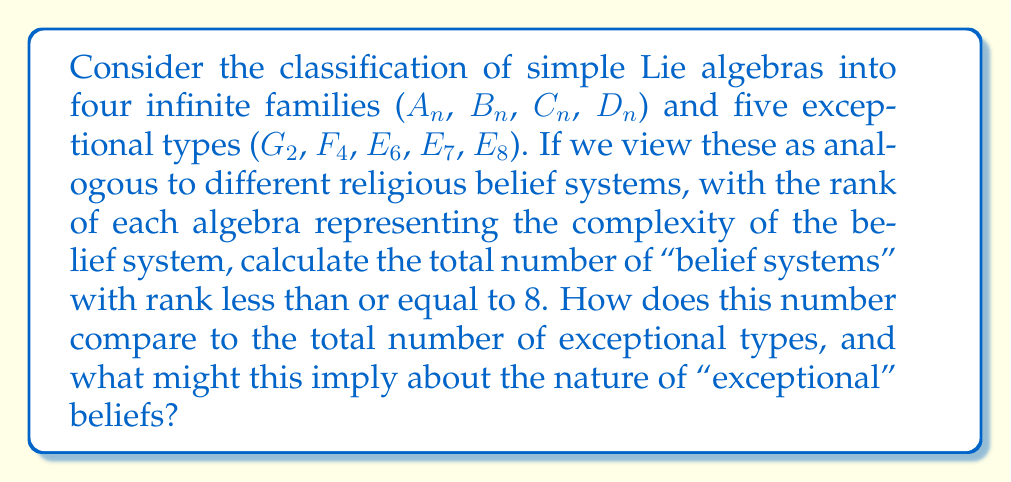Can you answer this question? To solve this problem, we need to count the number of simple Lie algebras with rank ≤ 8 for each family and add them together:

1. $A_n$ (rank $n$): $A_1, A_2, A_3, A_4, A_5, A_6, A_7, A_8$ (8 total)
2. $B_n$ (rank $n$, $n \geq 2$): $B_2, B_3, B_4, B_5, B_6, B_7, B_8$ (7 total)
3. $C_n$ (rank $n$, $n \geq 3$): $C_3, C_4, C_5, C_6, C_7, C_8$ (6 total)
4. $D_n$ (rank $n$, $n \geq 4$): $D_4, D_5, D_6, D_7, D_8$ (5 total)

For the exceptional types:
5. $G_2$ (rank 2): 1
6. $F_4$ (rank 4): 1
7. $E_6$ (rank 6): 1
8. $E_7$ (rank 7): 1
9. $E_8$ (rank 8): 1

Total number of "belief systems" with rank ≤ 8:
$$ 8 + 7 + 6 + 5 + 1 + 1 + 1 + 1 + 1 = 31 $$

The number of exceptional types is 5.

Comparison: $31 / 5 = 6.2$

This implies that the "exceptional" belief systems represent about 16.13% (5/31) of all belief systems with rank ≤ 8. In the context of deconstructing religious beliefs, this could suggest that while the majority of belief systems follow more common patterns (represented by the four infinite families), there exists a significant minority of "exceptional" belief systems that don't conform to these patterns.
Answer: There are 31 simple Lie algebras ("belief systems") with rank ≤ 8. This number is 6.2 times larger than the number of exceptional types (5), implying that exceptional beliefs represent approximately 16.13% of all belief systems in this classification. 